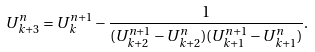Convert formula to latex. <formula><loc_0><loc_0><loc_500><loc_500>U _ { k + 3 } ^ { n } = U _ { k } ^ { n + 1 } - \frac { 1 } { ( U _ { k + 2 } ^ { n + 1 } - U _ { k + 2 } ^ { n } ) ( U _ { k + 1 } ^ { n + 1 } - U _ { k + 1 } ^ { n } ) } .</formula> 